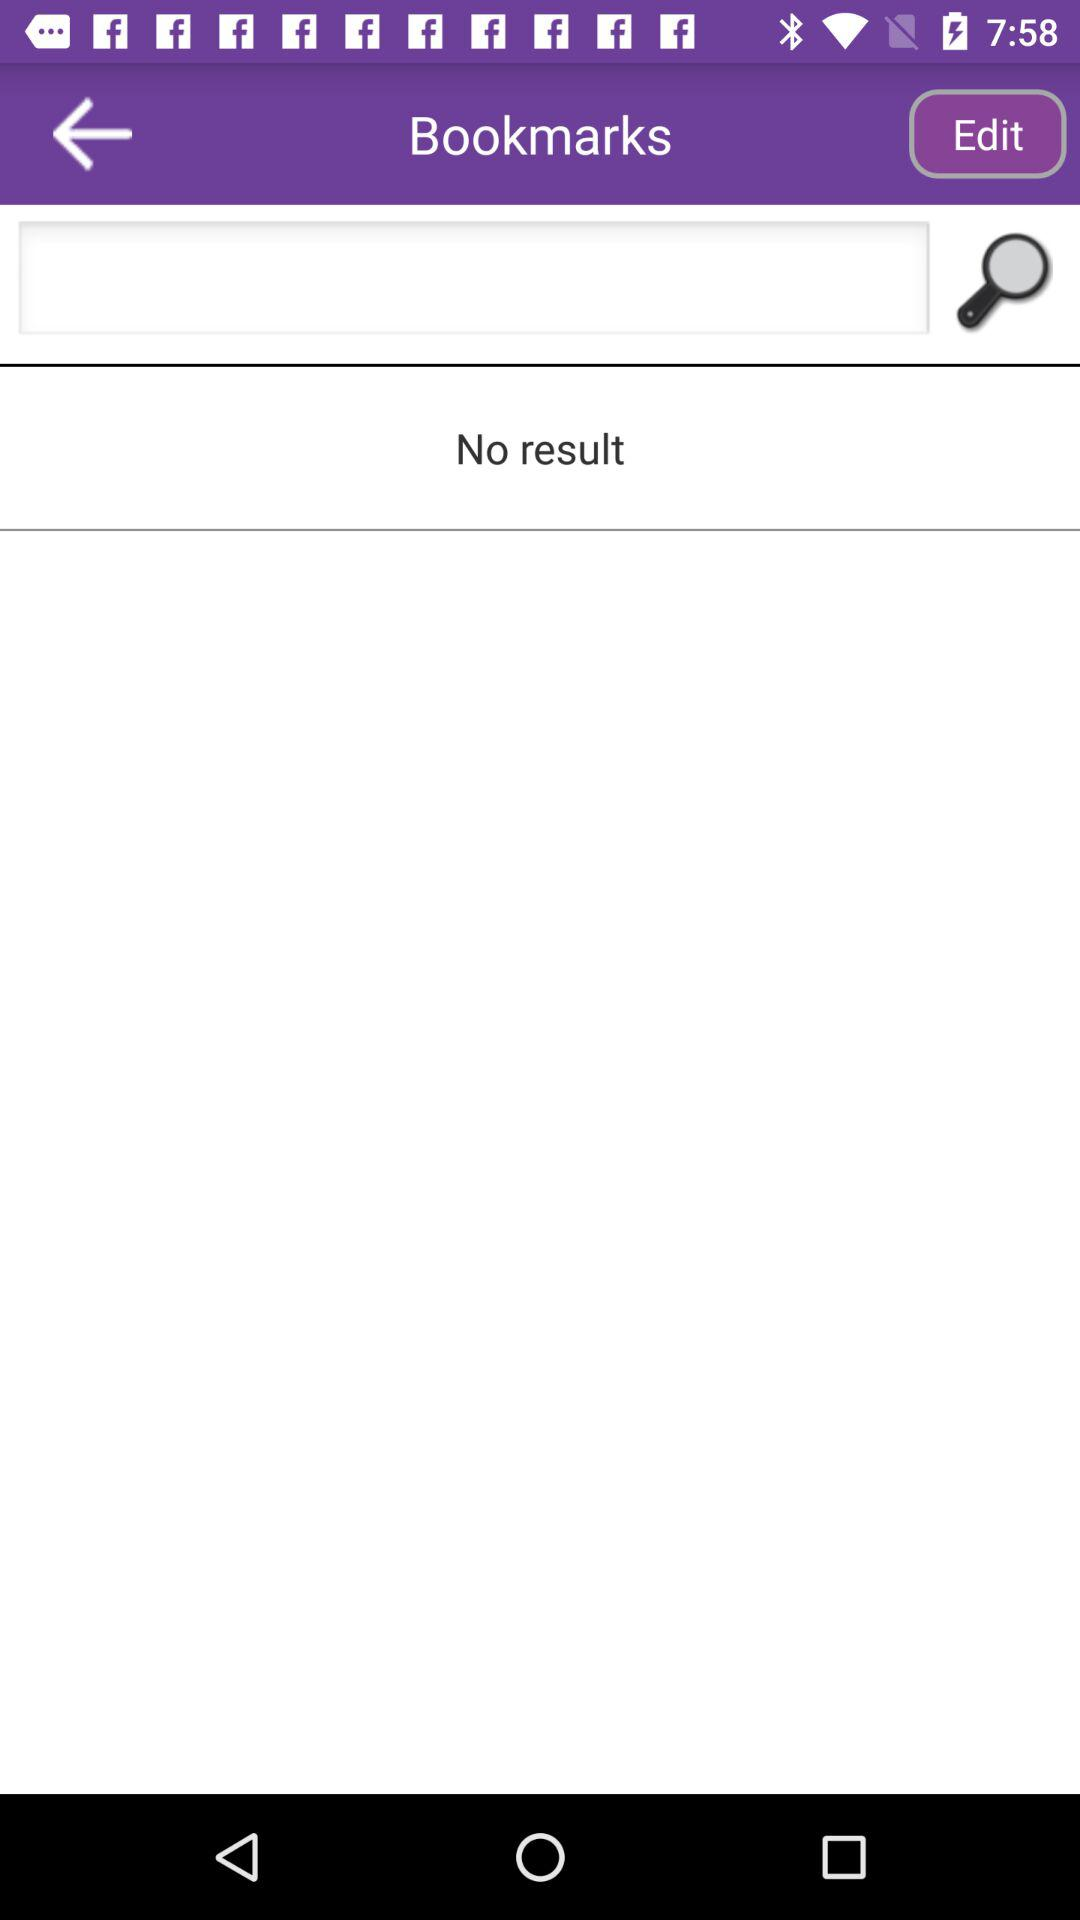Is there any result shown on the screen? There is no result shown on the screen. 